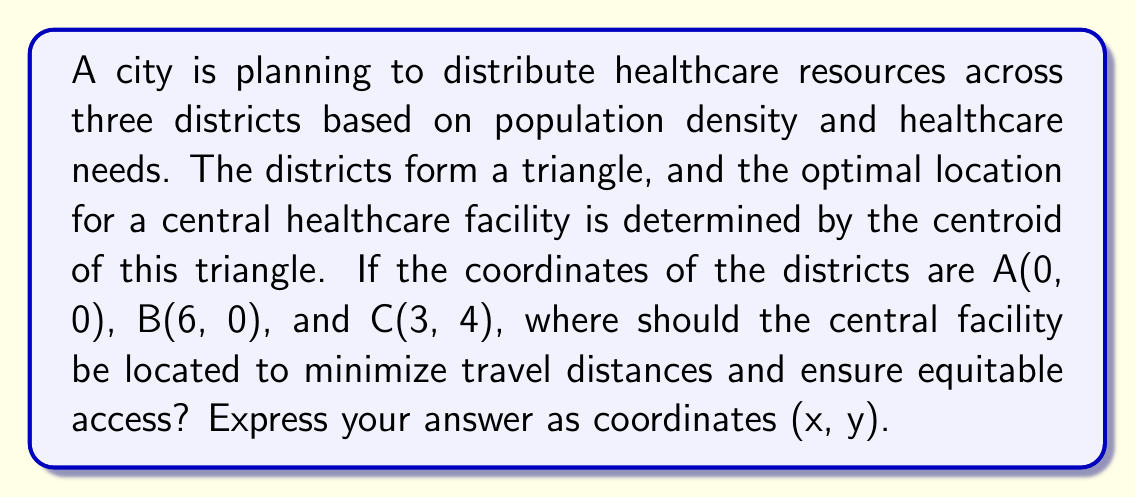Solve this math problem. To solve this problem, we need to find the centroid of the triangle formed by the three districts. The centroid is the arithmetic mean of the coordinates of the triangle's vertices.

Step 1: Identify the coordinates of the three points:
A(0, 0), B(6, 0), C(3, 4)

Step 2: Calculate the x-coordinate of the centroid:
$$ x = \frac{x_A + x_B + x_C}{3} = \frac{0 + 6 + 3}{3} = \frac{9}{3} = 3 $$

Step 3: Calculate the y-coordinate of the centroid:
$$ y = \frac{y_A + y_B + y_C}{3} = \frac{0 + 0 + 4}{3} = \frac{4}{3} \approx 1.33 $$

Step 4: Express the result as coordinates (x, y):
(3, 4/3)

This location minimizes the sum of distances from all three districts, ensuring equitable access to healthcare resources. It takes into account the population distribution represented by the triangle's shape, which is relevant to the legal considerations of reproductive rights and healthcare access.
Answer: (3, 4/3) 